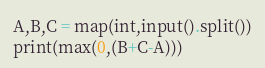<code> <loc_0><loc_0><loc_500><loc_500><_Python_>A,B,C = map(int,input().split())
print(max(0,(B+C-A)))</code> 